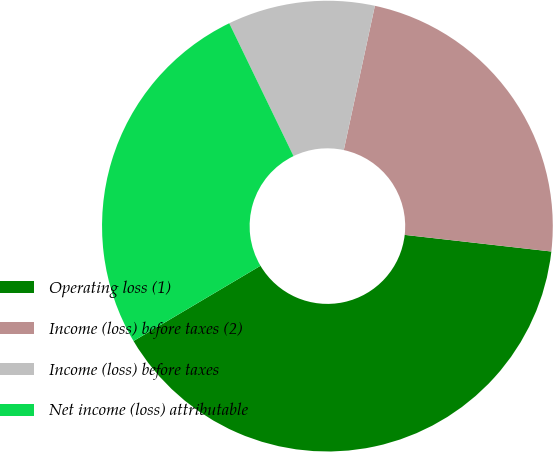<chart> <loc_0><loc_0><loc_500><loc_500><pie_chart><fcel>Operating loss (1)<fcel>Income (loss) before taxes (2)<fcel>Income (loss) before taxes<fcel>Net income (loss) attributable<nl><fcel>39.69%<fcel>23.42%<fcel>10.55%<fcel>26.34%<nl></chart> 